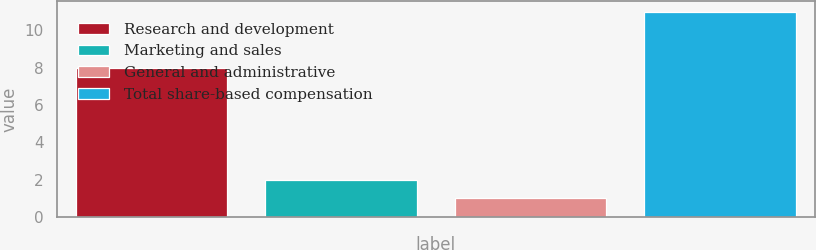<chart> <loc_0><loc_0><loc_500><loc_500><bar_chart><fcel>Research and development<fcel>Marketing and sales<fcel>General and administrative<fcel>Total share-based compensation<nl><fcel>8<fcel>2<fcel>1<fcel>11<nl></chart> 